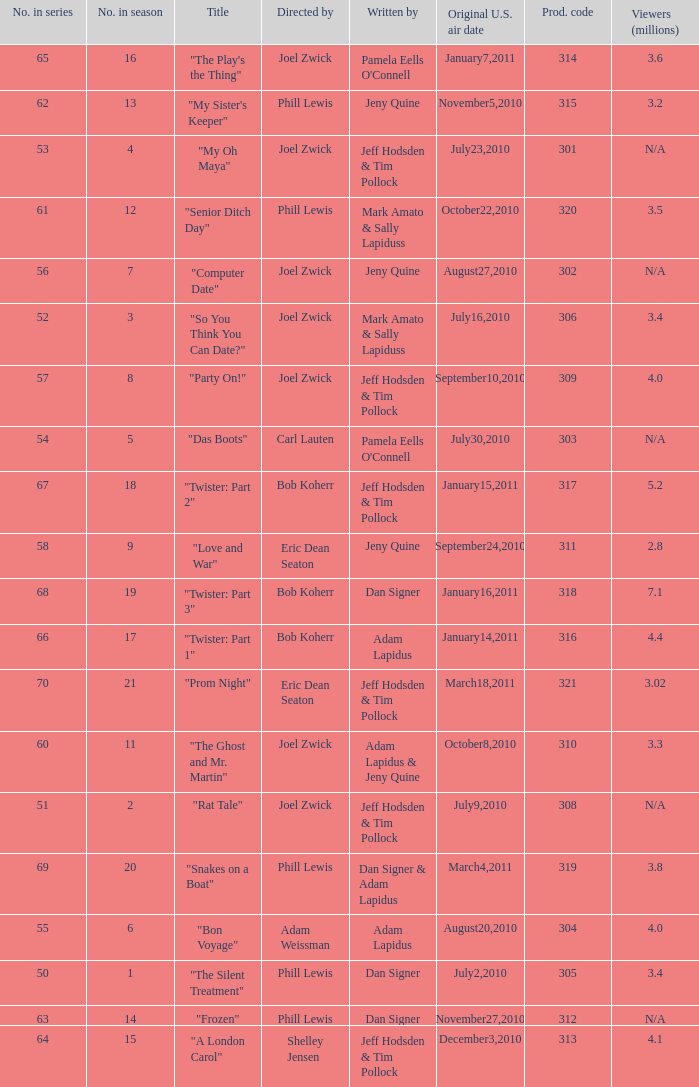What episode number was titled "my oh maya"? 4.0. 